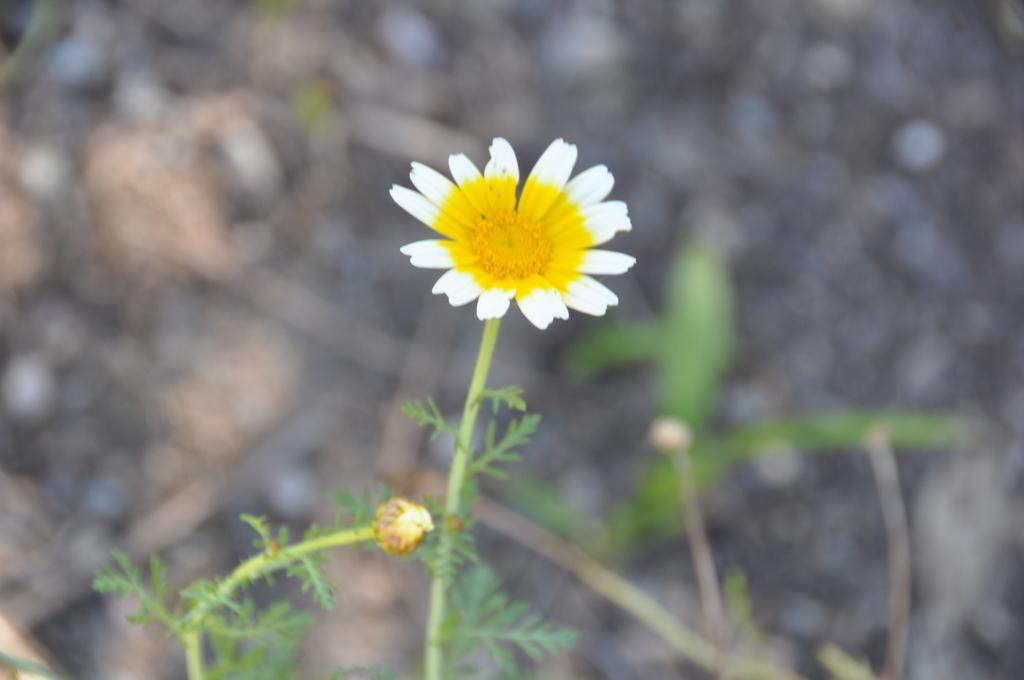What is the main subject in the middle of the image? There is a flower in the middle of the image. What else can be seen in the image besides the flower? There are plants in the image. What is the name of the person sneezing in the image? There is no person sneezing in the image; it features a flower and plants. 